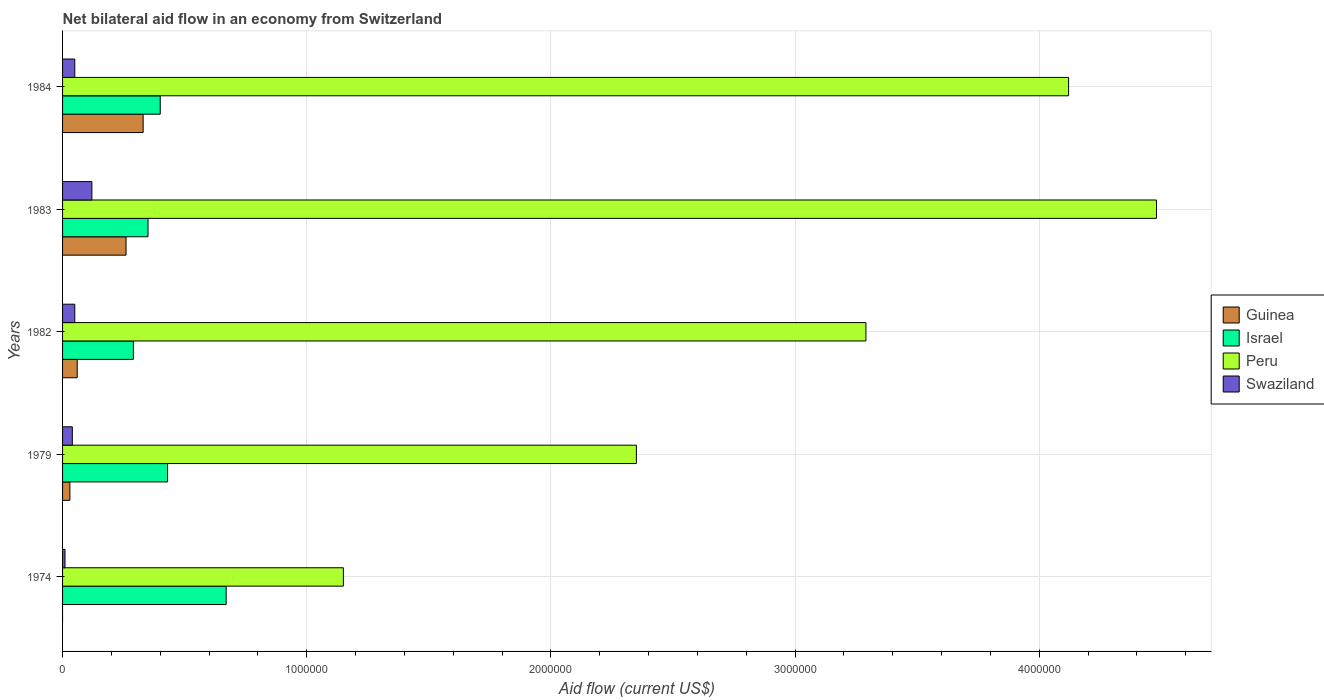How many different coloured bars are there?
Offer a terse response. 4. How many groups of bars are there?
Your answer should be compact. 5. Are the number of bars per tick equal to the number of legend labels?
Ensure brevity in your answer.  No. How many bars are there on the 5th tick from the bottom?
Keep it short and to the point. 4. What is the label of the 4th group of bars from the top?
Your answer should be compact. 1979. In how many cases, is the number of bars for a given year not equal to the number of legend labels?
Your response must be concise. 1. What is the net bilateral aid flow in Peru in 1983?
Offer a terse response. 4.48e+06. Across all years, what is the maximum net bilateral aid flow in Peru?
Make the answer very short. 4.48e+06. Across all years, what is the minimum net bilateral aid flow in Peru?
Keep it short and to the point. 1.15e+06. What is the total net bilateral aid flow in Swaziland in the graph?
Provide a succinct answer. 2.70e+05. What is the difference between the net bilateral aid flow in Swaziland in 1982 and that in 1983?
Your answer should be very brief. -7.00e+04. What is the difference between the net bilateral aid flow in Swaziland in 1979 and the net bilateral aid flow in Israel in 1983?
Ensure brevity in your answer.  -3.10e+05. What is the average net bilateral aid flow in Guinea per year?
Provide a short and direct response. 1.36e+05. In the year 1974, what is the difference between the net bilateral aid flow in Peru and net bilateral aid flow in Swaziland?
Offer a very short reply. 1.14e+06. In how many years, is the net bilateral aid flow in Peru greater than 800000 US$?
Your response must be concise. 5. What is the ratio of the net bilateral aid flow in Peru in 1974 to that in 1983?
Make the answer very short. 0.26. Is the difference between the net bilateral aid flow in Peru in 1974 and 1982 greater than the difference between the net bilateral aid flow in Swaziland in 1974 and 1982?
Provide a short and direct response. No. What is the difference between the highest and the second highest net bilateral aid flow in Guinea?
Offer a very short reply. 7.00e+04. Is the sum of the net bilateral aid flow in Israel in 1979 and 1983 greater than the maximum net bilateral aid flow in Swaziland across all years?
Provide a succinct answer. Yes. Is it the case that in every year, the sum of the net bilateral aid flow in Swaziland and net bilateral aid flow in Israel is greater than the sum of net bilateral aid flow in Peru and net bilateral aid flow in Guinea?
Offer a terse response. Yes. Is it the case that in every year, the sum of the net bilateral aid flow in Peru and net bilateral aid flow in Guinea is greater than the net bilateral aid flow in Swaziland?
Offer a terse response. Yes. How many bars are there?
Keep it short and to the point. 19. Are all the bars in the graph horizontal?
Give a very brief answer. Yes. What is the difference between two consecutive major ticks on the X-axis?
Provide a succinct answer. 1.00e+06. Does the graph contain any zero values?
Make the answer very short. Yes. Does the graph contain grids?
Provide a short and direct response. Yes. Where does the legend appear in the graph?
Offer a terse response. Center right. How many legend labels are there?
Offer a terse response. 4. How are the legend labels stacked?
Provide a short and direct response. Vertical. What is the title of the graph?
Your answer should be very brief. Net bilateral aid flow in an economy from Switzerland. What is the label or title of the X-axis?
Your answer should be very brief. Aid flow (current US$). What is the Aid flow (current US$) of Guinea in 1974?
Provide a short and direct response. 0. What is the Aid flow (current US$) in Israel in 1974?
Your answer should be compact. 6.70e+05. What is the Aid flow (current US$) of Peru in 1974?
Provide a short and direct response. 1.15e+06. What is the Aid flow (current US$) of Israel in 1979?
Give a very brief answer. 4.30e+05. What is the Aid flow (current US$) of Peru in 1979?
Offer a very short reply. 2.35e+06. What is the Aid flow (current US$) of Swaziland in 1979?
Make the answer very short. 4.00e+04. What is the Aid flow (current US$) of Israel in 1982?
Make the answer very short. 2.90e+05. What is the Aid flow (current US$) in Peru in 1982?
Your response must be concise. 3.29e+06. What is the Aid flow (current US$) in Guinea in 1983?
Your response must be concise. 2.60e+05. What is the Aid flow (current US$) in Peru in 1983?
Ensure brevity in your answer.  4.48e+06. What is the Aid flow (current US$) in Peru in 1984?
Keep it short and to the point. 4.12e+06. What is the Aid flow (current US$) of Swaziland in 1984?
Your answer should be very brief. 5.00e+04. Across all years, what is the maximum Aid flow (current US$) of Guinea?
Offer a very short reply. 3.30e+05. Across all years, what is the maximum Aid flow (current US$) of Israel?
Make the answer very short. 6.70e+05. Across all years, what is the maximum Aid flow (current US$) of Peru?
Offer a terse response. 4.48e+06. Across all years, what is the minimum Aid flow (current US$) in Peru?
Give a very brief answer. 1.15e+06. What is the total Aid flow (current US$) in Guinea in the graph?
Your answer should be compact. 6.80e+05. What is the total Aid flow (current US$) of Israel in the graph?
Keep it short and to the point. 2.14e+06. What is the total Aid flow (current US$) in Peru in the graph?
Keep it short and to the point. 1.54e+07. What is the total Aid flow (current US$) in Swaziland in the graph?
Give a very brief answer. 2.70e+05. What is the difference between the Aid flow (current US$) of Israel in 1974 and that in 1979?
Your answer should be compact. 2.40e+05. What is the difference between the Aid flow (current US$) in Peru in 1974 and that in 1979?
Keep it short and to the point. -1.20e+06. What is the difference between the Aid flow (current US$) in Peru in 1974 and that in 1982?
Provide a succinct answer. -2.14e+06. What is the difference between the Aid flow (current US$) in Israel in 1974 and that in 1983?
Keep it short and to the point. 3.20e+05. What is the difference between the Aid flow (current US$) in Peru in 1974 and that in 1983?
Provide a short and direct response. -3.33e+06. What is the difference between the Aid flow (current US$) in Israel in 1974 and that in 1984?
Offer a very short reply. 2.70e+05. What is the difference between the Aid flow (current US$) in Peru in 1974 and that in 1984?
Offer a very short reply. -2.97e+06. What is the difference between the Aid flow (current US$) in Peru in 1979 and that in 1982?
Provide a succinct answer. -9.40e+05. What is the difference between the Aid flow (current US$) in Swaziland in 1979 and that in 1982?
Make the answer very short. -10000. What is the difference between the Aid flow (current US$) in Israel in 1979 and that in 1983?
Your answer should be compact. 8.00e+04. What is the difference between the Aid flow (current US$) in Peru in 1979 and that in 1983?
Ensure brevity in your answer.  -2.13e+06. What is the difference between the Aid flow (current US$) in Peru in 1979 and that in 1984?
Your response must be concise. -1.77e+06. What is the difference between the Aid flow (current US$) in Peru in 1982 and that in 1983?
Offer a terse response. -1.19e+06. What is the difference between the Aid flow (current US$) in Peru in 1982 and that in 1984?
Give a very brief answer. -8.30e+05. What is the difference between the Aid flow (current US$) of Swaziland in 1982 and that in 1984?
Make the answer very short. 0. What is the difference between the Aid flow (current US$) in Israel in 1974 and the Aid flow (current US$) in Peru in 1979?
Offer a terse response. -1.68e+06. What is the difference between the Aid flow (current US$) in Israel in 1974 and the Aid flow (current US$) in Swaziland in 1979?
Provide a short and direct response. 6.30e+05. What is the difference between the Aid flow (current US$) in Peru in 1974 and the Aid flow (current US$) in Swaziland in 1979?
Provide a short and direct response. 1.11e+06. What is the difference between the Aid flow (current US$) of Israel in 1974 and the Aid flow (current US$) of Peru in 1982?
Provide a short and direct response. -2.62e+06. What is the difference between the Aid flow (current US$) in Israel in 1974 and the Aid flow (current US$) in Swaziland in 1982?
Your response must be concise. 6.20e+05. What is the difference between the Aid flow (current US$) in Peru in 1974 and the Aid flow (current US$) in Swaziland in 1982?
Provide a succinct answer. 1.10e+06. What is the difference between the Aid flow (current US$) of Israel in 1974 and the Aid flow (current US$) of Peru in 1983?
Your answer should be very brief. -3.81e+06. What is the difference between the Aid flow (current US$) of Peru in 1974 and the Aid flow (current US$) of Swaziland in 1983?
Provide a short and direct response. 1.03e+06. What is the difference between the Aid flow (current US$) of Israel in 1974 and the Aid flow (current US$) of Peru in 1984?
Your response must be concise. -3.45e+06. What is the difference between the Aid flow (current US$) in Israel in 1974 and the Aid flow (current US$) in Swaziland in 1984?
Offer a terse response. 6.20e+05. What is the difference between the Aid flow (current US$) in Peru in 1974 and the Aid flow (current US$) in Swaziland in 1984?
Provide a short and direct response. 1.10e+06. What is the difference between the Aid flow (current US$) in Guinea in 1979 and the Aid flow (current US$) in Peru in 1982?
Give a very brief answer. -3.26e+06. What is the difference between the Aid flow (current US$) in Guinea in 1979 and the Aid flow (current US$) in Swaziland in 1982?
Your response must be concise. -2.00e+04. What is the difference between the Aid flow (current US$) in Israel in 1979 and the Aid flow (current US$) in Peru in 1982?
Your answer should be compact. -2.86e+06. What is the difference between the Aid flow (current US$) of Israel in 1979 and the Aid flow (current US$) of Swaziland in 1982?
Ensure brevity in your answer.  3.80e+05. What is the difference between the Aid flow (current US$) of Peru in 1979 and the Aid flow (current US$) of Swaziland in 1982?
Provide a succinct answer. 2.30e+06. What is the difference between the Aid flow (current US$) in Guinea in 1979 and the Aid flow (current US$) in Israel in 1983?
Provide a succinct answer. -3.20e+05. What is the difference between the Aid flow (current US$) of Guinea in 1979 and the Aid flow (current US$) of Peru in 1983?
Your answer should be very brief. -4.45e+06. What is the difference between the Aid flow (current US$) of Guinea in 1979 and the Aid flow (current US$) of Swaziland in 1983?
Provide a short and direct response. -9.00e+04. What is the difference between the Aid flow (current US$) in Israel in 1979 and the Aid flow (current US$) in Peru in 1983?
Offer a terse response. -4.05e+06. What is the difference between the Aid flow (current US$) in Israel in 1979 and the Aid flow (current US$) in Swaziland in 1983?
Your answer should be compact. 3.10e+05. What is the difference between the Aid flow (current US$) in Peru in 1979 and the Aid flow (current US$) in Swaziland in 1983?
Offer a very short reply. 2.23e+06. What is the difference between the Aid flow (current US$) in Guinea in 1979 and the Aid flow (current US$) in Israel in 1984?
Your answer should be very brief. -3.70e+05. What is the difference between the Aid flow (current US$) of Guinea in 1979 and the Aid flow (current US$) of Peru in 1984?
Make the answer very short. -4.09e+06. What is the difference between the Aid flow (current US$) of Israel in 1979 and the Aid flow (current US$) of Peru in 1984?
Your answer should be compact. -3.69e+06. What is the difference between the Aid flow (current US$) of Peru in 1979 and the Aid flow (current US$) of Swaziland in 1984?
Make the answer very short. 2.30e+06. What is the difference between the Aid flow (current US$) of Guinea in 1982 and the Aid flow (current US$) of Peru in 1983?
Ensure brevity in your answer.  -4.42e+06. What is the difference between the Aid flow (current US$) of Guinea in 1982 and the Aid flow (current US$) of Swaziland in 1983?
Ensure brevity in your answer.  -6.00e+04. What is the difference between the Aid flow (current US$) of Israel in 1982 and the Aid flow (current US$) of Peru in 1983?
Provide a short and direct response. -4.19e+06. What is the difference between the Aid flow (current US$) of Israel in 1982 and the Aid flow (current US$) of Swaziland in 1983?
Provide a short and direct response. 1.70e+05. What is the difference between the Aid flow (current US$) in Peru in 1982 and the Aid flow (current US$) in Swaziland in 1983?
Make the answer very short. 3.17e+06. What is the difference between the Aid flow (current US$) in Guinea in 1982 and the Aid flow (current US$) in Israel in 1984?
Provide a succinct answer. -3.40e+05. What is the difference between the Aid flow (current US$) of Guinea in 1982 and the Aid flow (current US$) of Peru in 1984?
Give a very brief answer. -4.06e+06. What is the difference between the Aid flow (current US$) in Guinea in 1982 and the Aid flow (current US$) in Swaziland in 1984?
Provide a succinct answer. 10000. What is the difference between the Aid flow (current US$) of Israel in 1982 and the Aid flow (current US$) of Peru in 1984?
Provide a succinct answer. -3.83e+06. What is the difference between the Aid flow (current US$) of Peru in 1982 and the Aid flow (current US$) of Swaziland in 1984?
Your answer should be very brief. 3.24e+06. What is the difference between the Aid flow (current US$) of Guinea in 1983 and the Aid flow (current US$) of Peru in 1984?
Keep it short and to the point. -3.86e+06. What is the difference between the Aid flow (current US$) of Guinea in 1983 and the Aid flow (current US$) of Swaziland in 1984?
Ensure brevity in your answer.  2.10e+05. What is the difference between the Aid flow (current US$) in Israel in 1983 and the Aid flow (current US$) in Peru in 1984?
Provide a succinct answer. -3.77e+06. What is the difference between the Aid flow (current US$) of Israel in 1983 and the Aid flow (current US$) of Swaziland in 1984?
Give a very brief answer. 3.00e+05. What is the difference between the Aid flow (current US$) in Peru in 1983 and the Aid flow (current US$) in Swaziland in 1984?
Keep it short and to the point. 4.43e+06. What is the average Aid flow (current US$) in Guinea per year?
Offer a terse response. 1.36e+05. What is the average Aid flow (current US$) in Israel per year?
Make the answer very short. 4.28e+05. What is the average Aid flow (current US$) of Peru per year?
Give a very brief answer. 3.08e+06. What is the average Aid flow (current US$) in Swaziland per year?
Your answer should be compact. 5.40e+04. In the year 1974, what is the difference between the Aid flow (current US$) of Israel and Aid flow (current US$) of Peru?
Give a very brief answer. -4.80e+05. In the year 1974, what is the difference between the Aid flow (current US$) of Peru and Aid flow (current US$) of Swaziland?
Make the answer very short. 1.14e+06. In the year 1979, what is the difference between the Aid flow (current US$) of Guinea and Aid flow (current US$) of Israel?
Your response must be concise. -4.00e+05. In the year 1979, what is the difference between the Aid flow (current US$) in Guinea and Aid flow (current US$) in Peru?
Keep it short and to the point. -2.32e+06. In the year 1979, what is the difference between the Aid flow (current US$) in Israel and Aid flow (current US$) in Peru?
Provide a succinct answer. -1.92e+06. In the year 1979, what is the difference between the Aid flow (current US$) in Israel and Aid flow (current US$) in Swaziland?
Offer a terse response. 3.90e+05. In the year 1979, what is the difference between the Aid flow (current US$) in Peru and Aid flow (current US$) in Swaziland?
Provide a short and direct response. 2.31e+06. In the year 1982, what is the difference between the Aid flow (current US$) of Guinea and Aid flow (current US$) of Peru?
Ensure brevity in your answer.  -3.23e+06. In the year 1982, what is the difference between the Aid flow (current US$) in Peru and Aid flow (current US$) in Swaziland?
Provide a short and direct response. 3.24e+06. In the year 1983, what is the difference between the Aid flow (current US$) in Guinea and Aid flow (current US$) in Peru?
Offer a terse response. -4.22e+06. In the year 1983, what is the difference between the Aid flow (current US$) in Israel and Aid flow (current US$) in Peru?
Ensure brevity in your answer.  -4.13e+06. In the year 1983, what is the difference between the Aid flow (current US$) in Israel and Aid flow (current US$) in Swaziland?
Provide a short and direct response. 2.30e+05. In the year 1983, what is the difference between the Aid flow (current US$) in Peru and Aid flow (current US$) in Swaziland?
Your response must be concise. 4.36e+06. In the year 1984, what is the difference between the Aid flow (current US$) of Guinea and Aid flow (current US$) of Israel?
Your answer should be compact. -7.00e+04. In the year 1984, what is the difference between the Aid flow (current US$) in Guinea and Aid flow (current US$) in Peru?
Make the answer very short. -3.79e+06. In the year 1984, what is the difference between the Aid flow (current US$) of Israel and Aid flow (current US$) of Peru?
Offer a terse response. -3.72e+06. In the year 1984, what is the difference between the Aid flow (current US$) of Peru and Aid flow (current US$) of Swaziland?
Offer a very short reply. 4.07e+06. What is the ratio of the Aid flow (current US$) in Israel in 1974 to that in 1979?
Offer a very short reply. 1.56. What is the ratio of the Aid flow (current US$) in Peru in 1974 to that in 1979?
Offer a terse response. 0.49. What is the ratio of the Aid flow (current US$) of Swaziland in 1974 to that in 1979?
Ensure brevity in your answer.  0.25. What is the ratio of the Aid flow (current US$) of Israel in 1974 to that in 1982?
Your response must be concise. 2.31. What is the ratio of the Aid flow (current US$) of Peru in 1974 to that in 1982?
Your answer should be very brief. 0.35. What is the ratio of the Aid flow (current US$) in Swaziland in 1974 to that in 1982?
Keep it short and to the point. 0.2. What is the ratio of the Aid flow (current US$) in Israel in 1974 to that in 1983?
Offer a very short reply. 1.91. What is the ratio of the Aid flow (current US$) in Peru in 1974 to that in 1983?
Provide a short and direct response. 0.26. What is the ratio of the Aid flow (current US$) of Swaziland in 1974 to that in 1983?
Your answer should be very brief. 0.08. What is the ratio of the Aid flow (current US$) in Israel in 1974 to that in 1984?
Provide a short and direct response. 1.68. What is the ratio of the Aid flow (current US$) of Peru in 1974 to that in 1984?
Keep it short and to the point. 0.28. What is the ratio of the Aid flow (current US$) of Guinea in 1979 to that in 1982?
Provide a short and direct response. 0.5. What is the ratio of the Aid flow (current US$) of Israel in 1979 to that in 1982?
Provide a succinct answer. 1.48. What is the ratio of the Aid flow (current US$) in Guinea in 1979 to that in 1983?
Your answer should be very brief. 0.12. What is the ratio of the Aid flow (current US$) of Israel in 1979 to that in 1983?
Your answer should be compact. 1.23. What is the ratio of the Aid flow (current US$) of Peru in 1979 to that in 1983?
Offer a terse response. 0.52. What is the ratio of the Aid flow (current US$) of Guinea in 1979 to that in 1984?
Provide a succinct answer. 0.09. What is the ratio of the Aid flow (current US$) of Israel in 1979 to that in 1984?
Your response must be concise. 1.07. What is the ratio of the Aid flow (current US$) of Peru in 1979 to that in 1984?
Your response must be concise. 0.57. What is the ratio of the Aid flow (current US$) in Swaziland in 1979 to that in 1984?
Give a very brief answer. 0.8. What is the ratio of the Aid flow (current US$) in Guinea in 1982 to that in 1983?
Offer a very short reply. 0.23. What is the ratio of the Aid flow (current US$) in Israel in 1982 to that in 1983?
Your answer should be compact. 0.83. What is the ratio of the Aid flow (current US$) of Peru in 1982 to that in 1983?
Offer a very short reply. 0.73. What is the ratio of the Aid flow (current US$) of Swaziland in 1982 to that in 1983?
Provide a short and direct response. 0.42. What is the ratio of the Aid flow (current US$) of Guinea in 1982 to that in 1984?
Offer a very short reply. 0.18. What is the ratio of the Aid flow (current US$) in Israel in 1982 to that in 1984?
Your answer should be very brief. 0.72. What is the ratio of the Aid flow (current US$) of Peru in 1982 to that in 1984?
Make the answer very short. 0.8. What is the ratio of the Aid flow (current US$) of Swaziland in 1982 to that in 1984?
Your response must be concise. 1. What is the ratio of the Aid flow (current US$) in Guinea in 1983 to that in 1984?
Your response must be concise. 0.79. What is the ratio of the Aid flow (current US$) in Israel in 1983 to that in 1984?
Keep it short and to the point. 0.88. What is the ratio of the Aid flow (current US$) in Peru in 1983 to that in 1984?
Provide a succinct answer. 1.09. What is the ratio of the Aid flow (current US$) in Swaziland in 1983 to that in 1984?
Your response must be concise. 2.4. What is the difference between the highest and the second highest Aid flow (current US$) in Guinea?
Provide a succinct answer. 7.00e+04. What is the difference between the highest and the second highest Aid flow (current US$) of Peru?
Ensure brevity in your answer.  3.60e+05. What is the difference between the highest and the second highest Aid flow (current US$) in Swaziland?
Make the answer very short. 7.00e+04. What is the difference between the highest and the lowest Aid flow (current US$) in Israel?
Your answer should be very brief. 3.80e+05. What is the difference between the highest and the lowest Aid flow (current US$) in Peru?
Ensure brevity in your answer.  3.33e+06. What is the difference between the highest and the lowest Aid flow (current US$) of Swaziland?
Offer a very short reply. 1.10e+05. 